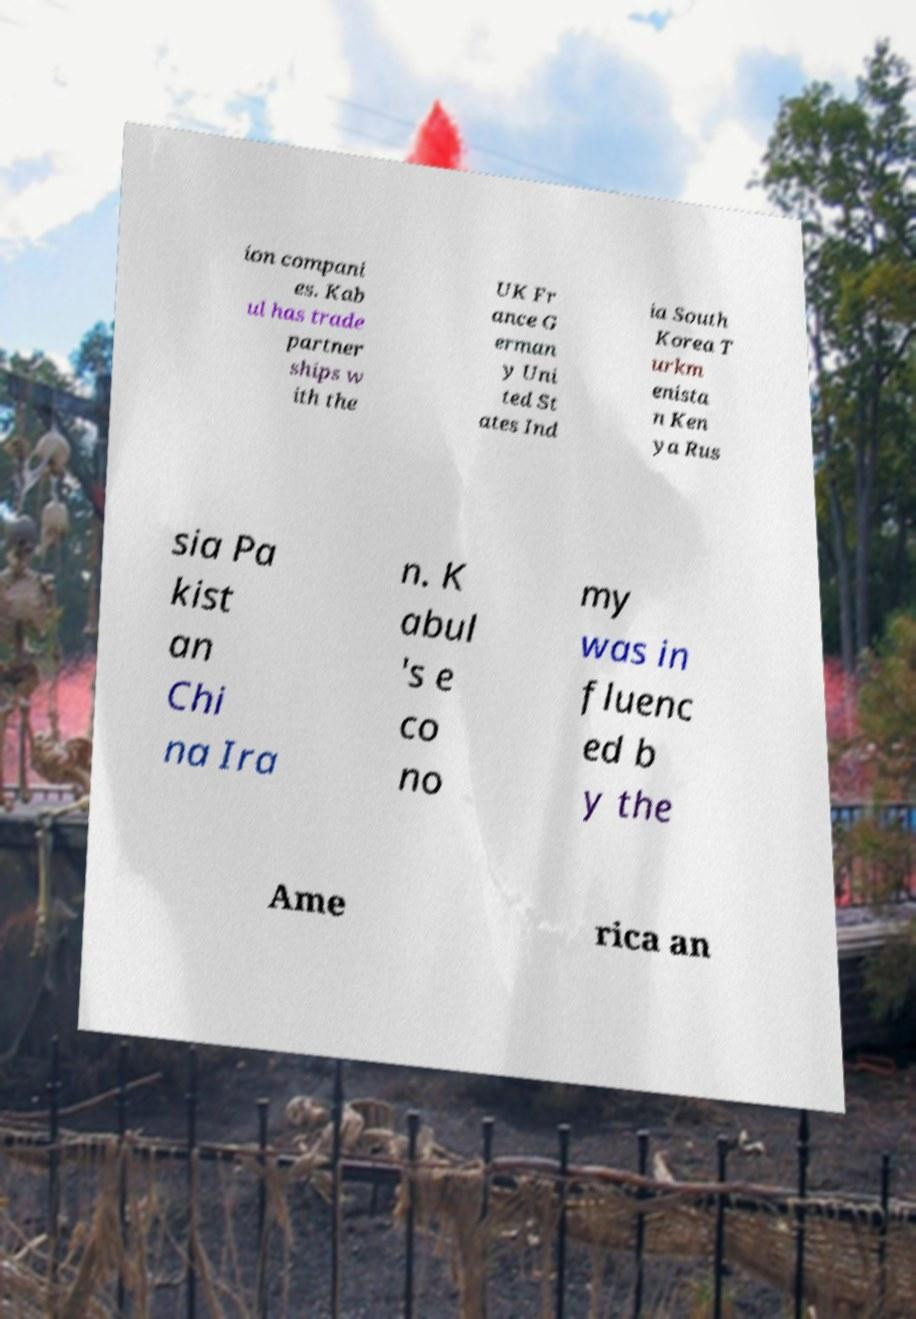There's text embedded in this image that I need extracted. Can you transcribe it verbatim? ion compani es. Kab ul has trade partner ships w ith the UK Fr ance G erman y Uni ted St ates Ind ia South Korea T urkm enista n Ken ya Rus sia Pa kist an Chi na Ira n. K abul 's e co no my was in fluenc ed b y the Ame rica an 